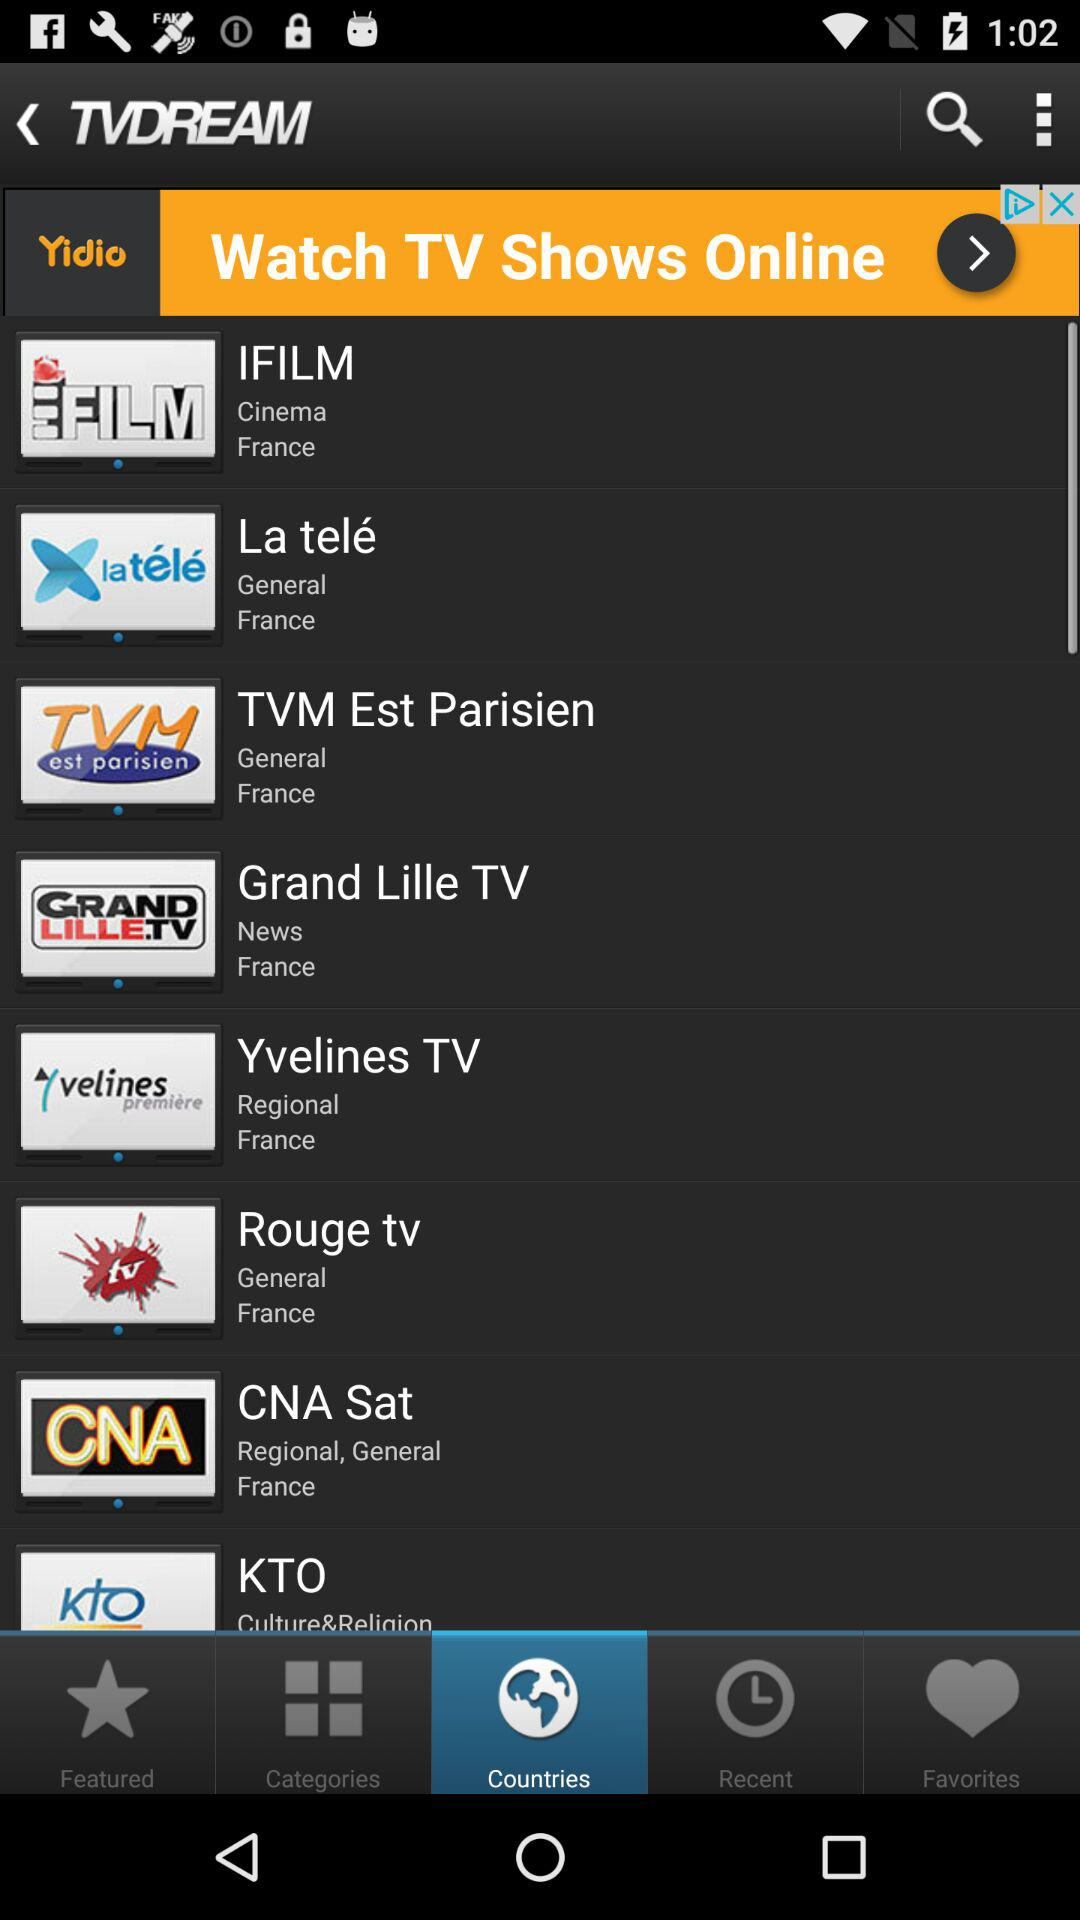What is the name of the application? The name of the application is "TVDREAM". 